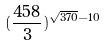Convert formula to latex. <formula><loc_0><loc_0><loc_500><loc_500>( \frac { 4 5 8 } { 3 } ) ^ { \sqrt { 3 7 0 } - 1 0 }</formula> 